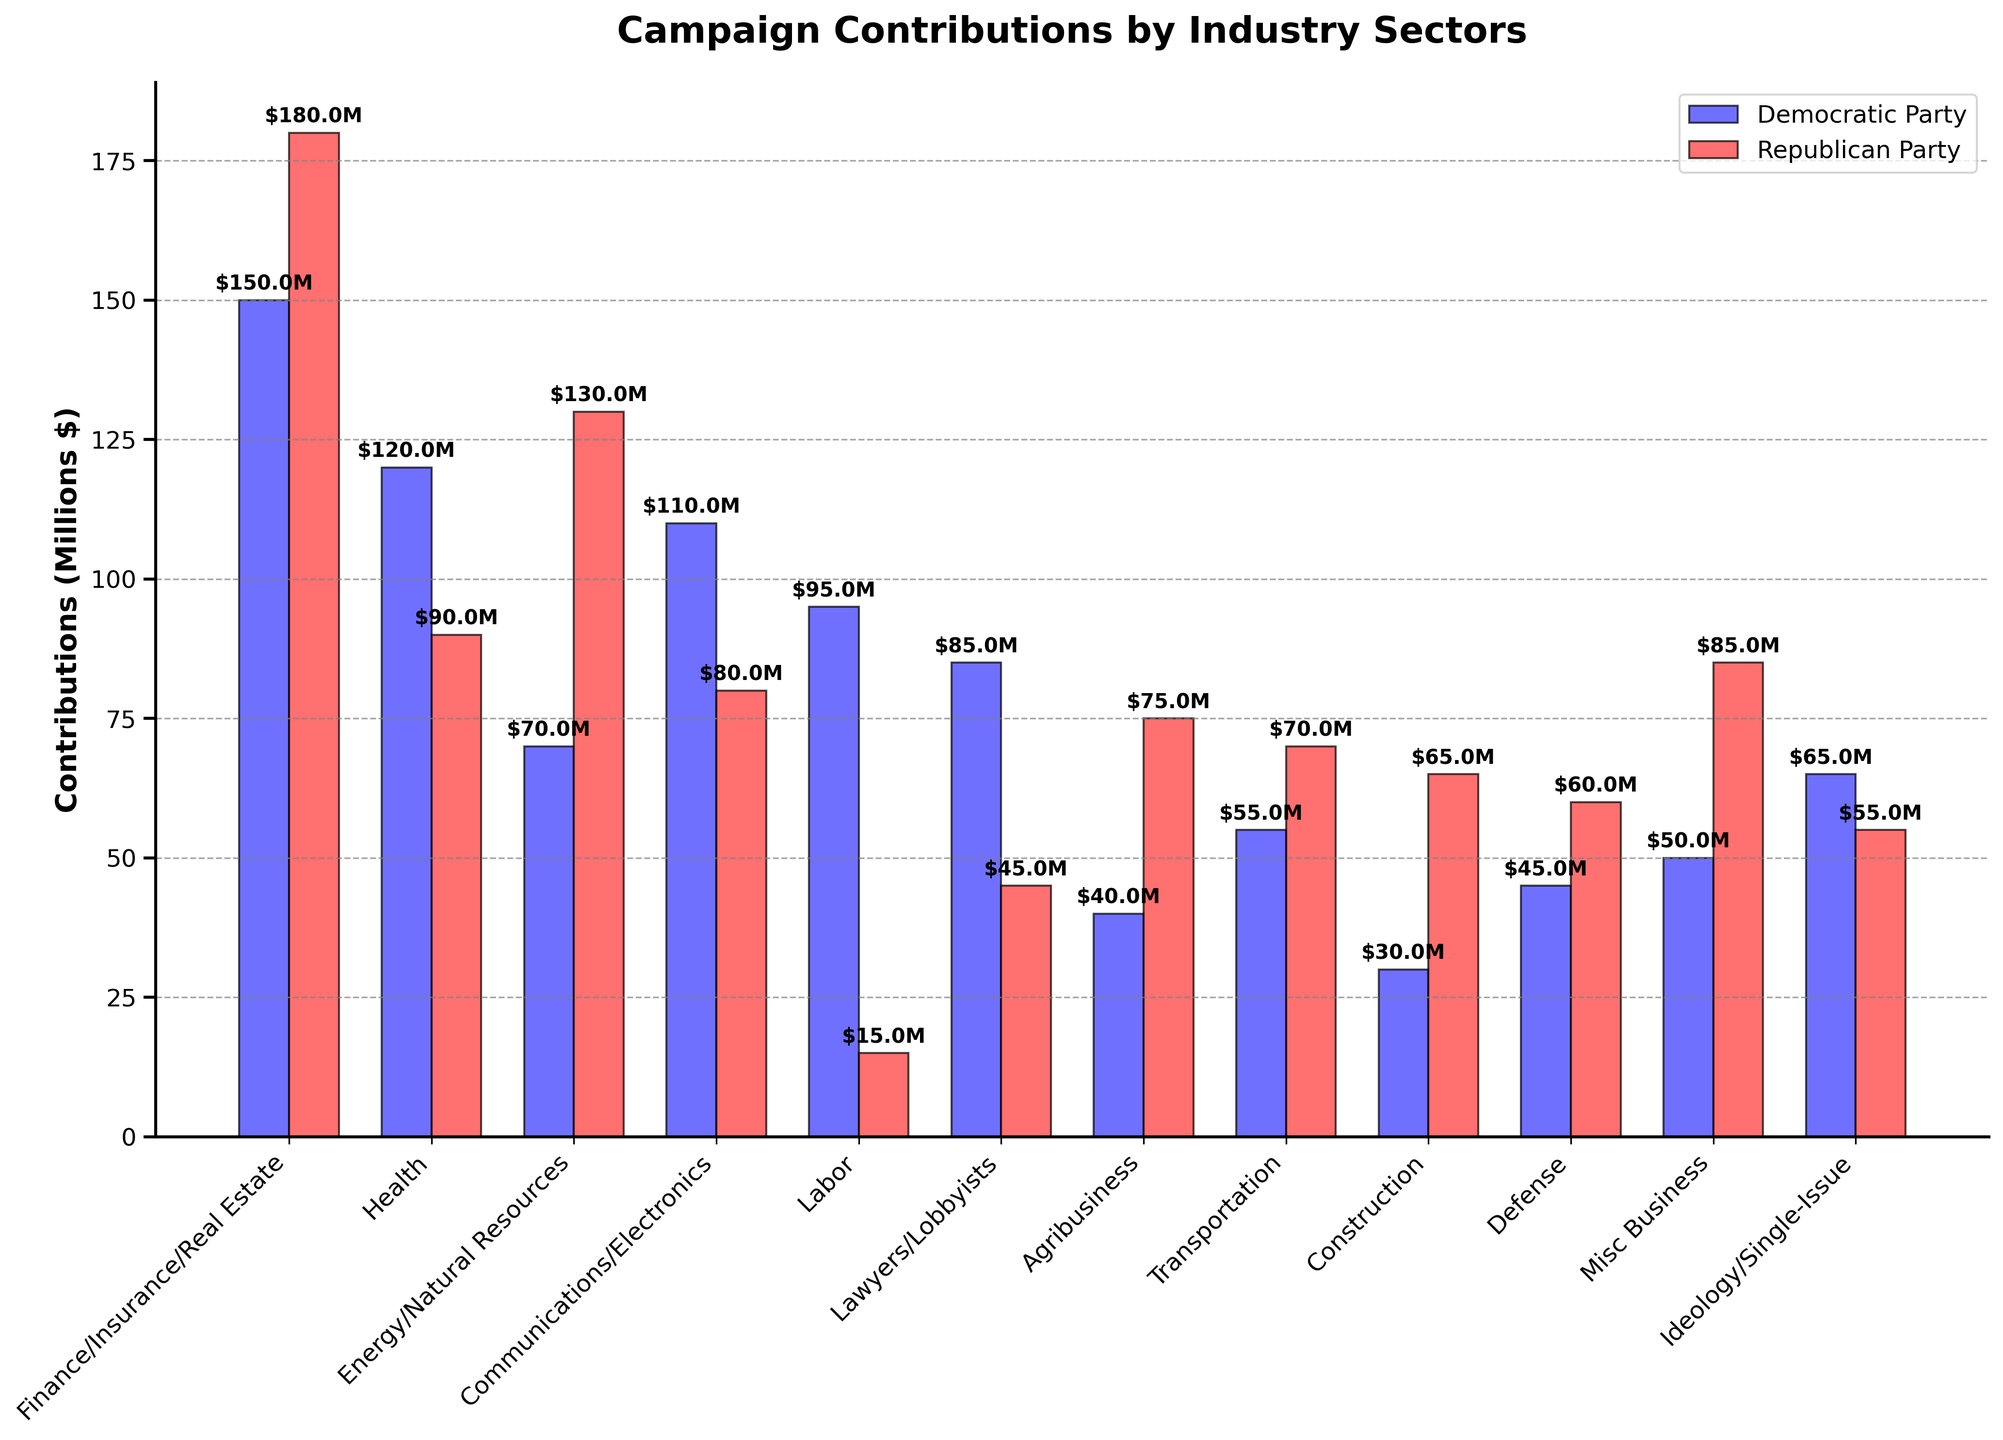Which industry sector gave the highest contributions to the Democratic Party? Looking at the figure, the highest bar for the Democratic Party is for the Finance/Insurance/Real Estate sector.
Answer: Finance/Insurance/Real Estate Which industry contributed more to the Republican Party than the Democratic Party? Industries with higher red (Republican) bars compared to blue (Democratic) are Finance/Insurance/Real Estate, Energy/Natural Resources, Agribusiness, Transportation, Construction, Defense, and Misc Business.
Answer: Finance/Insurance/Real Estate, Energy/Natural Resources, Agribusiness, Transportation, Construction, Defense, Misc Business What is the total contribution from the Health sector to both parties combined? Summing the contributions from the Health sector for both parties: 120M (Democratic) + 90M (Republican) = 210M.
Answer: 210M Which two industry sectors showed approximately equal contributions to the Republican Party? The figure shows that the contributions from the Labor and Lawyers/Lobbyists sectors to the Republican Party are close to 15M and 45M respectively. These industries are not approximately equal; hence, the better-matched sectors would be Communications/Electronics (80M) and the Ideology/Single-Issue (55M) which both are not equal.
Answer: None are approximately equal What is the difference in contributions to the Republican Party between the Energy/Natural Resources and Health sectors? Calculating the difference: 130M (Energy/Natural Resources) - 90M (Health) = 40M.
Answer: 40M Which party received more total contributions? Summing up contributions for each party: Democratic Party = 150 + 120 + 70 + 110 + 95 + 85 + 40 + 55 + 30 + 45 + 50 + 65 = 915M, Republican Party = 180 + 90 + 130 + 80 + 15 + 45 + 75 + 70 + 65 + 60 + 85 + 55 = 950M. The Republican Party received more.
Answer: Republican Party How much more did the Finance/Insurance/Real Estate sector contribute to the Republican Party compared to the Democratic Party? Subtracting Democratic contributions from Republican contributions in this sector: 180M - 150M = 30M.
Answer: 30M Which industry's contributions to the Democratic Party are closest to 100 million USD? The figure shows the Communications/Electronics sector's contributions to the Democratic Party is approximately 110M, the closest to 100M.
Answer: Communications/Electronics Comparing contributions to the Lawyers/Lobbyists sector, how much more did the Democratic Party receive than the Republican Party? Calculating the difference in contributions: 85M (Democratic) - 45M (Republican) = 40M.
Answer: 40M 